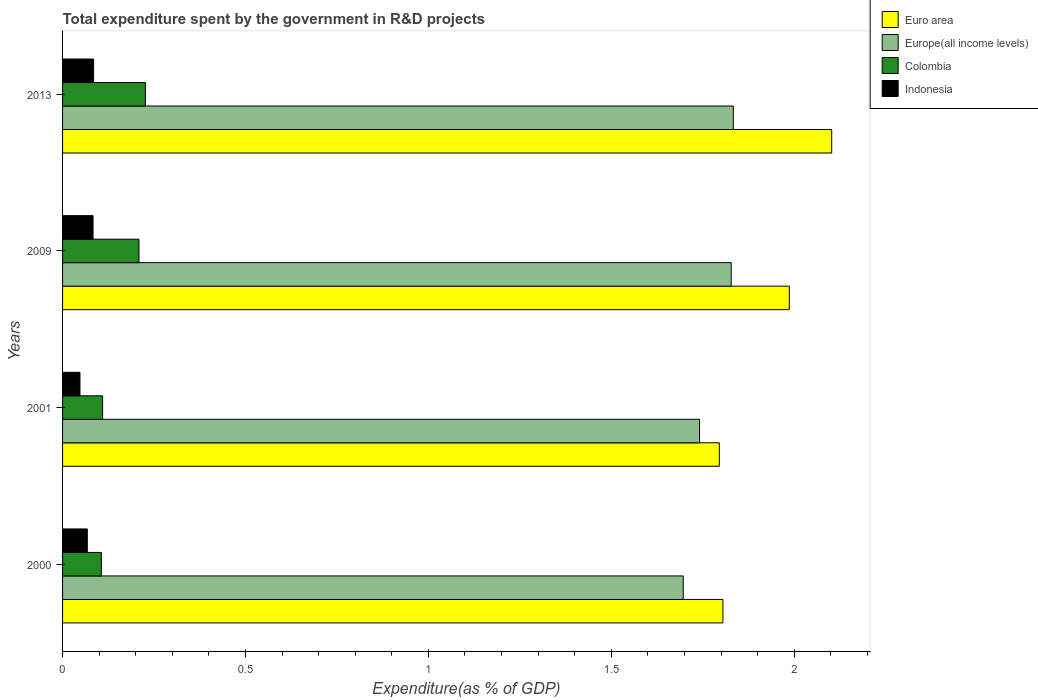How many different coloured bars are there?
Your response must be concise. 4. How many groups of bars are there?
Provide a short and direct response. 4. Are the number of bars per tick equal to the number of legend labels?
Offer a very short reply. Yes. Are the number of bars on each tick of the Y-axis equal?
Offer a very short reply. Yes. What is the label of the 2nd group of bars from the top?
Your answer should be very brief. 2009. In how many cases, is the number of bars for a given year not equal to the number of legend labels?
Your answer should be compact. 0. What is the total expenditure spent by the government in R&D projects in Colombia in 2009?
Make the answer very short. 0.21. Across all years, what is the maximum total expenditure spent by the government in R&D projects in Europe(all income levels)?
Provide a short and direct response. 1.83. Across all years, what is the minimum total expenditure spent by the government in R&D projects in Indonesia?
Offer a very short reply. 0.05. In which year was the total expenditure spent by the government in R&D projects in Colombia minimum?
Provide a succinct answer. 2000. What is the total total expenditure spent by the government in R&D projects in Euro area in the graph?
Your response must be concise. 7.69. What is the difference between the total expenditure spent by the government in R&D projects in Europe(all income levels) in 2001 and that in 2009?
Offer a very short reply. -0.09. What is the difference between the total expenditure spent by the government in R&D projects in Euro area in 2009 and the total expenditure spent by the government in R&D projects in Colombia in 2001?
Offer a terse response. 1.88. What is the average total expenditure spent by the government in R&D projects in Colombia per year?
Offer a very short reply. 0.16. In the year 2000, what is the difference between the total expenditure spent by the government in R&D projects in Euro area and total expenditure spent by the government in R&D projects in Colombia?
Your answer should be very brief. 1.7. What is the ratio of the total expenditure spent by the government in R&D projects in Europe(all income levels) in 2001 to that in 2013?
Provide a succinct answer. 0.95. Is the total expenditure spent by the government in R&D projects in Europe(all income levels) in 2001 less than that in 2013?
Make the answer very short. Yes. Is the difference between the total expenditure spent by the government in R&D projects in Euro area in 2009 and 2013 greater than the difference between the total expenditure spent by the government in R&D projects in Colombia in 2009 and 2013?
Ensure brevity in your answer.  No. What is the difference between the highest and the second highest total expenditure spent by the government in R&D projects in Euro area?
Your response must be concise. 0.12. What is the difference between the highest and the lowest total expenditure spent by the government in R&D projects in Colombia?
Keep it short and to the point. 0.12. Is it the case that in every year, the sum of the total expenditure spent by the government in R&D projects in Colombia and total expenditure spent by the government in R&D projects in Europe(all income levels) is greater than the sum of total expenditure spent by the government in R&D projects in Indonesia and total expenditure spent by the government in R&D projects in Euro area?
Make the answer very short. Yes. What does the 2nd bar from the top in 2000 represents?
Keep it short and to the point. Colombia. What does the 3rd bar from the bottom in 2001 represents?
Provide a succinct answer. Colombia. Is it the case that in every year, the sum of the total expenditure spent by the government in R&D projects in Colombia and total expenditure spent by the government in R&D projects in Europe(all income levels) is greater than the total expenditure spent by the government in R&D projects in Euro area?
Give a very brief answer. No. How many years are there in the graph?
Make the answer very short. 4. What is the difference between two consecutive major ticks on the X-axis?
Provide a short and direct response. 0.5. How many legend labels are there?
Give a very brief answer. 4. How are the legend labels stacked?
Your answer should be very brief. Vertical. What is the title of the graph?
Provide a succinct answer. Total expenditure spent by the government in R&D projects. Does "Afghanistan" appear as one of the legend labels in the graph?
Your response must be concise. No. What is the label or title of the X-axis?
Provide a succinct answer. Expenditure(as % of GDP). What is the Expenditure(as % of GDP) of Euro area in 2000?
Provide a short and direct response. 1.81. What is the Expenditure(as % of GDP) in Europe(all income levels) in 2000?
Offer a very short reply. 1.7. What is the Expenditure(as % of GDP) in Colombia in 2000?
Ensure brevity in your answer.  0.11. What is the Expenditure(as % of GDP) of Indonesia in 2000?
Offer a very short reply. 0.07. What is the Expenditure(as % of GDP) in Euro area in 2001?
Your answer should be very brief. 1.8. What is the Expenditure(as % of GDP) in Europe(all income levels) in 2001?
Keep it short and to the point. 1.74. What is the Expenditure(as % of GDP) in Colombia in 2001?
Offer a terse response. 0.11. What is the Expenditure(as % of GDP) of Indonesia in 2001?
Provide a succinct answer. 0.05. What is the Expenditure(as % of GDP) in Euro area in 2009?
Offer a terse response. 1.99. What is the Expenditure(as % of GDP) in Europe(all income levels) in 2009?
Keep it short and to the point. 1.83. What is the Expenditure(as % of GDP) of Colombia in 2009?
Make the answer very short. 0.21. What is the Expenditure(as % of GDP) in Indonesia in 2009?
Your response must be concise. 0.08. What is the Expenditure(as % of GDP) in Euro area in 2013?
Your response must be concise. 2.1. What is the Expenditure(as % of GDP) in Europe(all income levels) in 2013?
Your response must be concise. 1.83. What is the Expenditure(as % of GDP) of Colombia in 2013?
Make the answer very short. 0.23. What is the Expenditure(as % of GDP) in Indonesia in 2013?
Make the answer very short. 0.08. Across all years, what is the maximum Expenditure(as % of GDP) in Euro area?
Give a very brief answer. 2.1. Across all years, what is the maximum Expenditure(as % of GDP) of Europe(all income levels)?
Provide a short and direct response. 1.83. Across all years, what is the maximum Expenditure(as % of GDP) in Colombia?
Offer a terse response. 0.23. Across all years, what is the maximum Expenditure(as % of GDP) of Indonesia?
Offer a very short reply. 0.08. Across all years, what is the minimum Expenditure(as % of GDP) in Euro area?
Your response must be concise. 1.8. Across all years, what is the minimum Expenditure(as % of GDP) in Europe(all income levels)?
Provide a short and direct response. 1.7. Across all years, what is the minimum Expenditure(as % of GDP) in Colombia?
Keep it short and to the point. 0.11. Across all years, what is the minimum Expenditure(as % of GDP) of Indonesia?
Ensure brevity in your answer.  0.05. What is the total Expenditure(as % of GDP) of Euro area in the graph?
Your response must be concise. 7.69. What is the total Expenditure(as % of GDP) in Europe(all income levels) in the graph?
Offer a terse response. 7.1. What is the total Expenditure(as % of GDP) in Colombia in the graph?
Keep it short and to the point. 0.65. What is the total Expenditure(as % of GDP) in Indonesia in the graph?
Keep it short and to the point. 0.28. What is the difference between the Expenditure(as % of GDP) of Euro area in 2000 and that in 2001?
Offer a very short reply. 0.01. What is the difference between the Expenditure(as % of GDP) in Europe(all income levels) in 2000 and that in 2001?
Your response must be concise. -0.04. What is the difference between the Expenditure(as % of GDP) in Colombia in 2000 and that in 2001?
Your answer should be very brief. -0. What is the difference between the Expenditure(as % of GDP) in Indonesia in 2000 and that in 2001?
Give a very brief answer. 0.02. What is the difference between the Expenditure(as % of GDP) in Euro area in 2000 and that in 2009?
Offer a very short reply. -0.18. What is the difference between the Expenditure(as % of GDP) of Europe(all income levels) in 2000 and that in 2009?
Make the answer very short. -0.13. What is the difference between the Expenditure(as % of GDP) of Colombia in 2000 and that in 2009?
Offer a terse response. -0.1. What is the difference between the Expenditure(as % of GDP) in Indonesia in 2000 and that in 2009?
Ensure brevity in your answer.  -0.02. What is the difference between the Expenditure(as % of GDP) of Euro area in 2000 and that in 2013?
Provide a succinct answer. -0.3. What is the difference between the Expenditure(as % of GDP) of Europe(all income levels) in 2000 and that in 2013?
Ensure brevity in your answer.  -0.14. What is the difference between the Expenditure(as % of GDP) of Colombia in 2000 and that in 2013?
Your answer should be compact. -0.12. What is the difference between the Expenditure(as % of GDP) in Indonesia in 2000 and that in 2013?
Provide a succinct answer. -0.02. What is the difference between the Expenditure(as % of GDP) of Euro area in 2001 and that in 2009?
Make the answer very short. -0.19. What is the difference between the Expenditure(as % of GDP) of Europe(all income levels) in 2001 and that in 2009?
Make the answer very short. -0.09. What is the difference between the Expenditure(as % of GDP) in Colombia in 2001 and that in 2009?
Provide a short and direct response. -0.1. What is the difference between the Expenditure(as % of GDP) in Indonesia in 2001 and that in 2009?
Your answer should be compact. -0.04. What is the difference between the Expenditure(as % of GDP) in Euro area in 2001 and that in 2013?
Offer a very short reply. -0.31. What is the difference between the Expenditure(as % of GDP) in Europe(all income levels) in 2001 and that in 2013?
Your response must be concise. -0.09. What is the difference between the Expenditure(as % of GDP) of Colombia in 2001 and that in 2013?
Make the answer very short. -0.12. What is the difference between the Expenditure(as % of GDP) of Indonesia in 2001 and that in 2013?
Your response must be concise. -0.04. What is the difference between the Expenditure(as % of GDP) in Euro area in 2009 and that in 2013?
Keep it short and to the point. -0.12. What is the difference between the Expenditure(as % of GDP) of Europe(all income levels) in 2009 and that in 2013?
Make the answer very short. -0.01. What is the difference between the Expenditure(as % of GDP) in Colombia in 2009 and that in 2013?
Keep it short and to the point. -0.02. What is the difference between the Expenditure(as % of GDP) of Indonesia in 2009 and that in 2013?
Offer a very short reply. -0. What is the difference between the Expenditure(as % of GDP) in Euro area in 2000 and the Expenditure(as % of GDP) in Europe(all income levels) in 2001?
Your response must be concise. 0.06. What is the difference between the Expenditure(as % of GDP) in Euro area in 2000 and the Expenditure(as % of GDP) in Colombia in 2001?
Your answer should be very brief. 1.7. What is the difference between the Expenditure(as % of GDP) of Euro area in 2000 and the Expenditure(as % of GDP) of Indonesia in 2001?
Your response must be concise. 1.76. What is the difference between the Expenditure(as % of GDP) in Europe(all income levels) in 2000 and the Expenditure(as % of GDP) in Colombia in 2001?
Provide a succinct answer. 1.59. What is the difference between the Expenditure(as % of GDP) in Europe(all income levels) in 2000 and the Expenditure(as % of GDP) in Indonesia in 2001?
Give a very brief answer. 1.65. What is the difference between the Expenditure(as % of GDP) of Colombia in 2000 and the Expenditure(as % of GDP) of Indonesia in 2001?
Your answer should be compact. 0.06. What is the difference between the Expenditure(as % of GDP) of Euro area in 2000 and the Expenditure(as % of GDP) of Europe(all income levels) in 2009?
Offer a terse response. -0.02. What is the difference between the Expenditure(as % of GDP) of Euro area in 2000 and the Expenditure(as % of GDP) of Colombia in 2009?
Ensure brevity in your answer.  1.6. What is the difference between the Expenditure(as % of GDP) of Euro area in 2000 and the Expenditure(as % of GDP) of Indonesia in 2009?
Provide a succinct answer. 1.72. What is the difference between the Expenditure(as % of GDP) in Europe(all income levels) in 2000 and the Expenditure(as % of GDP) in Colombia in 2009?
Your response must be concise. 1.49. What is the difference between the Expenditure(as % of GDP) of Europe(all income levels) in 2000 and the Expenditure(as % of GDP) of Indonesia in 2009?
Offer a terse response. 1.61. What is the difference between the Expenditure(as % of GDP) of Colombia in 2000 and the Expenditure(as % of GDP) of Indonesia in 2009?
Give a very brief answer. 0.02. What is the difference between the Expenditure(as % of GDP) of Euro area in 2000 and the Expenditure(as % of GDP) of Europe(all income levels) in 2013?
Your answer should be compact. -0.03. What is the difference between the Expenditure(as % of GDP) in Euro area in 2000 and the Expenditure(as % of GDP) in Colombia in 2013?
Keep it short and to the point. 1.58. What is the difference between the Expenditure(as % of GDP) of Euro area in 2000 and the Expenditure(as % of GDP) of Indonesia in 2013?
Ensure brevity in your answer.  1.72. What is the difference between the Expenditure(as % of GDP) of Europe(all income levels) in 2000 and the Expenditure(as % of GDP) of Colombia in 2013?
Your response must be concise. 1.47. What is the difference between the Expenditure(as % of GDP) of Europe(all income levels) in 2000 and the Expenditure(as % of GDP) of Indonesia in 2013?
Offer a terse response. 1.61. What is the difference between the Expenditure(as % of GDP) of Colombia in 2000 and the Expenditure(as % of GDP) of Indonesia in 2013?
Provide a succinct answer. 0.02. What is the difference between the Expenditure(as % of GDP) in Euro area in 2001 and the Expenditure(as % of GDP) in Europe(all income levels) in 2009?
Provide a short and direct response. -0.03. What is the difference between the Expenditure(as % of GDP) of Euro area in 2001 and the Expenditure(as % of GDP) of Colombia in 2009?
Ensure brevity in your answer.  1.59. What is the difference between the Expenditure(as % of GDP) in Euro area in 2001 and the Expenditure(as % of GDP) in Indonesia in 2009?
Make the answer very short. 1.71. What is the difference between the Expenditure(as % of GDP) in Europe(all income levels) in 2001 and the Expenditure(as % of GDP) in Colombia in 2009?
Give a very brief answer. 1.53. What is the difference between the Expenditure(as % of GDP) of Europe(all income levels) in 2001 and the Expenditure(as % of GDP) of Indonesia in 2009?
Make the answer very short. 1.66. What is the difference between the Expenditure(as % of GDP) of Colombia in 2001 and the Expenditure(as % of GDP) of Indonesia in 2009?
Your answer should be compact. 0.03. What is the difference between the Expenditure(as % of GDP) in Euro area in 2001 and the Expenditure(as % of GDP) in Europe(all income levels) in 2013?
Provide a short and direct response. -0.04. What is the difference between the Expenditure(as % of GDP) in Euro area in 2001 and the Expenditure(as % of GDP) in Colombia in 2013?
Your response must be concise. 1.57. What is the difference between the Expenditure(as % of GDP) of Euro area in 2001 and the Expenditure(as % of GDP) of Indonesia in 2013?
Offer a very short reply. 1.71. What is the difference between the Expenditure(as % of GDP) of Europe(all income levels) in 2001 and the Expenditure(as % of GDP) of Colombia in 2013?
Your answer should be very brief. 1.51. What is the difference between the Expenditure(as % of GDP) in Europe(all income levels) in 2001 and the Expenditure(as % of GDP) in Indonesia in 2013?
Give a very brief answer. 1.66. What is the difference between the Expenditure(as % of GDP) in Colombia in 2001 and the Expenditure(as % of GDP) in Indonesia in 2013?
Give a very brief answer. 0.02. What is the difference between the Expenditure(as % of GDP) of Euro area in 2009 and the Expenditure(as % of GDP) of Europe(all income levels) in 2013?
Make the answer very short. 0.15. What is the difference between the Expenditure(as % of GDP) of Euro area in 2009 and the Expenditure(as % of GDP) of Colombia in 2013?
Offer a very short reply. 1.76. What is the difference between the Expenditure(as % of GDP) of Euro area in 2009 and the Expenditure(as % of GDP) of Indonesia in 2013?
Make the answer very short. 1.9. What is the difference between the Expenditure(as % of GDP) in Europe(all income levels) in 2009 and the Expenditure(as % of GDP) in Colombia in 2013?
Ensure brevity in your answer.  1.6. What is the difference between the Expenditure(as % of GDP) of Europe(all income levels) in 2009 and the Expenditure(as % of GDP) of Indonesia in 2013?
Make the answer very short. 1.74. What is the difference between the Expenditure(as % of GDP) in Colombia in 2009 and the Expenditure(as % of GDP) in Indonesia in 2013?
Provide a succinct answer. 0.12. What is the average Expenditure(as % of GDP) in Euro area per year?
Make the answer very short. 1.92. What is the average Expenditure(as % of GDP) of Europe(all income levels) per year?
Your answer should be compact. 1.77. What is the average Expenditure(as % of GDP) in Colombia per year?
Provide a succinct answer. 0.16. What is the average Expenditure(as % of GDP) in Indonesia per year?
Your answer should be very brief. 0.07. In the year 2000, what is the difference between the Expenditure(as % of GDP) in Euro area and Expenditure(as % of GDP) in Europe(all income levels)?
Ensure brevity in your answer.  0.11. In the year 2000, what is the difference between the Expenditure(as % of GDP) in Euro area and Expenditure(as % of GDP) in Colombia?
Your answer should be compact. 1.7. In the year 2000, what is the difference between the Expenditure(as % of GDP) in Euro area and Expenditure(as % of GDP) in Indonesia?
Offer a terse response. 1.74. In the year 2000, what is the difference between the Expenditure(as % of GDP) in Europe(all income levels) and Expenditure(as % of GDP) in Colombia?
Your response must be concise. 1.59. In the year 2000, what is the difference between the Expenditure(as % of GDP) of Europe(all income levels) and Expenditure(as % of GDP) of Indonesia?
Your answer should be very brief. 1.63. In the year 2000, what is the difference between the Expenditure(as % of GDP) of Colombia and Expenditure(as % of GDP) of Indonesia?
Provide a short and direct response. 0.04. In the year 2001, what is the difference between the Expenditure(as % of GDP) in Euro area and Expenditure(as % of GDP) in Europe(all income levels)?
Your response must be concise. 0.05. In the year 2001, what is the difference between the Expenditure(as % of GDP) of Euro area and Expenditure(as % of GDP) of Colombia?
Ensure brevity in your answer.  1.69. In the year 2001, what is the difference between the Expenditure(as % of GDP) in Euro area and Expenditure(as % of GDP) in Indonesia?
Your answer should be compact. 1.75. In the year 2001, what is the difference between the Expenditure(as % of GDP) in Europe(all income levels) and Expenditure(as % of GDP) in Colombia?
Ensure brevity in your answer.  1.63. In the year 2001, what is the difference between the Expenditure(as % of GDP) in Europe(all income levels) and Expenditure(as % of GDP) in Indonesia?
Your response must be concise. 1.69. In the year 2001, what is the difference between the Expenditure(as % of GDP) in Colombia and Expenditure(as % of GDP) in Indonesia?
Your response must be concise. 0.06. In the year 2009, what is the difference between the Expenditure(as % of GDP) in Euro area and Expenditure(as % of GDP) in Europe(all income levels)?
Keep it short and to the point. 0.16. In the year 2009, what is the difference between the Expenditure(as % of GDP) in Euro area and Expenditure(as % of GDP) in Colombia?
Your answer should be compact. 1.78. In the year 2009, what is the difference between the Expenditure(as % of GDP) of Euro area and Expenditure(as % of GDP) of Indonesia?
Give a very brief answer. 1.9. In the year 2009, what is the difference between the Expenditure(as % of GDP) of Europe(all income levels) and Expenditure(as % of GDP) of Colombia?
Your answer should be very brief. 1.62. In the year 2009, what is the difference between the Expenditure(as % of GDP) of Europe(all income levels) and Expenditure(as % of GDP) of Indonesia?
Ensure brevity in your answer.  1.74. In the year 2009, what is the difference between the Expenditure(as % of GDP) in Colombia and Expenditure(as % of GDP) in Indonesia?
Offer a very short reply. 0.13. In the year 2013, what is the difference between the Expenditure(as % of GDP) in Euro area and Expenditure(as % of GDP) in Europe(all income levels)?
Offer a terse response. 0.27. In the year 2013, what is the difference between the Expenditure(as % of GDP) in Euro area and Expenditure(as % of GDP) in Colombia?
Your response must be concise. 1.88. In the year 2013, what is the difference between the Expenditure(as % of GDP) in Euro area and Expenditure(as % of GDP) in Indonesia?
Ensure brevity in your answer.  2.02. In the year 2013, what is the difference between the Expenditure(as % of GDP) in Europe(all income levels) and Expenditure(as % of GDP) in Colombia?
Keep it short and to the point. 1.61. In the year 2013, what is the difference between the Expenditure(as % of GDP) of Europe(all income levels) and Expenditure(as % of GDP) of Indonesia?
Offer a terse response. 1.75. In the year 2013, what is the difference between the Expenditure(as % of GDP) of Colombia and Expenditure(as % of GDP) of Indonesia?
Offer a terse response. 0.14. What is the ratio of the Expenditure(as % of GDP) in Euro area in 2000 to that in 2001?
Your response must be concise. 1.01. What is the ratio of the Expenditure(as % of GDP) in Europe(all income levels) in 2000 to that in 2001?
Provide a short and direct response. 0.97. What is the ratio of the Expenditure(as % of GDP) of Colombia in 2000 to that in 2001?
Provide a succinct answer. 0.97. What is the ratio of the Expenditure(as % of GDP) of Indonesia in 2000 to that in 2001?
Make the answer very short. 1.42. What is the ratio of the Expenditure(as % of GDP) of Euro area in 2000 to that in 2009?
Offer a very short reply. 0.91. What is the ratio of the Expenditure(as % of GDP) in Europe(all income levels) in 2000 to that in 2009?
Provide a succinct answer. 0.93. What is the ratio of the Expenditure(as % of GDP) in Colombia in 2000 to that in 2009?
Your answer should be compact. 0.51. What is the ratio of the Expenditure(as % of GDP) in Indonesia in 2000 to that in 2009?
Offer a very short reply. 0.81. What is the ratio of the Expenditure(as % of GDP) of Euro area in 2000 to that in 2013?
Your answer should be very brief. 0.86. What is the ratio of the Expenditure(as % of GDP) in Europe(all income levels) in 2000 to that in 2013?
Your response must be concise. 0.93. What is the ratio of the Expenditure(as % of GDP) in Colombia in 2000 to that in 2013?
Give a very brief answer. 0.47. What is the ratio of the Expenditure(as % of GDP) in Indonesia in 2000 to that in 2013?
Offer a terse response. 0.8. What is the ratio of the Expenditure(as % of GDP) of Euro area in 2001 to that in 2009?
Your response must be concise. 0.9. What is the ratio of the Expenditure(as % of GDP) in Europe(all income levels) in 2001 to that in 2009?
Offer a terse response. 0.95. What is the ratio of the Expenditure(as % of GDP) of Colombia in 2001 to that in 2009?
Offer a very short reply. 0.52. What is the ratio of the Expenditure(as % of GDP) in Indonesia in 2001 to that in 2009?
Give a very brief answer. 0.57. What is the ratio of the Expenditure(as % of GDP) in Euro area in 2001 to that in 2013?
Provide a short and direct response. 0.85. What is the ratio of the Expenditure(as % of GDP) in Europe(all income levels) in 2001 to that in 2013?
Offer a very short reply. 0.95. What is the ratio of the Expenditure(as % of GDP) in Colombia in 2001 to that in 2013?
Your answer should be compact. 0.48. What is the ratio of the Expenditure(as % of GDP) in Indonesia in 2001 to that in 2013?
Provide a succinct answer. 0.56. What is the ratio of the Expenditure(as % of GDP) of Euro area in 2009 to that in 2013?
Provide a short and direct response. 0.94. What is the ratio of the Expenditure(as % of GDP) of Europe(all income levels) in 2009 to that in 2013?
Offer a terse response. 1. What is the ratio of the Expenditure(as % of GDP) in Colombia in 2009 to that in 2013?
Your answer should be very brief. 0.92. What is the ratio of the Expenditure(as % of GDP) in Indonesia in 2009 to that in 2013?
Your answer should be very brief. 0.98. What is the difference between the highest and the second highest Expenditure(as % of GDP) in Euro area?
Offer a terse response. 0.12. What is the difference between the highest and the second highest Expenditure(as % of GDP) of Europe(all income levels)?
Your answer should be compact. 0.01. What is the difference between the highest and the second highest Expenditure(as % of GDP) of Colombia?
Offer a very short reply. 0.02. What is the difference between the highest and the second highest Expenditure(as % of GDP) of Indonesia?
Make the answer very short. 0. What is the difference between the highest and the lowest Expenditure(as % of GDP) in Euro area?
Provide a succinct answer. 0.31. What is the difference between the highest and the lowest Expenditure(as % of GDP) of Europe(all income levels)?
Offer a terse response. 0.14. What is the difference between the highest and the lowest Expenditure(as % of GDP) in Colombia?
Keep it short and to the point. 0.12. What is the difference between the highest and the lowest Expenditure(as % of GDP) of Indonesia?
Make the answer very short. 0.04. 